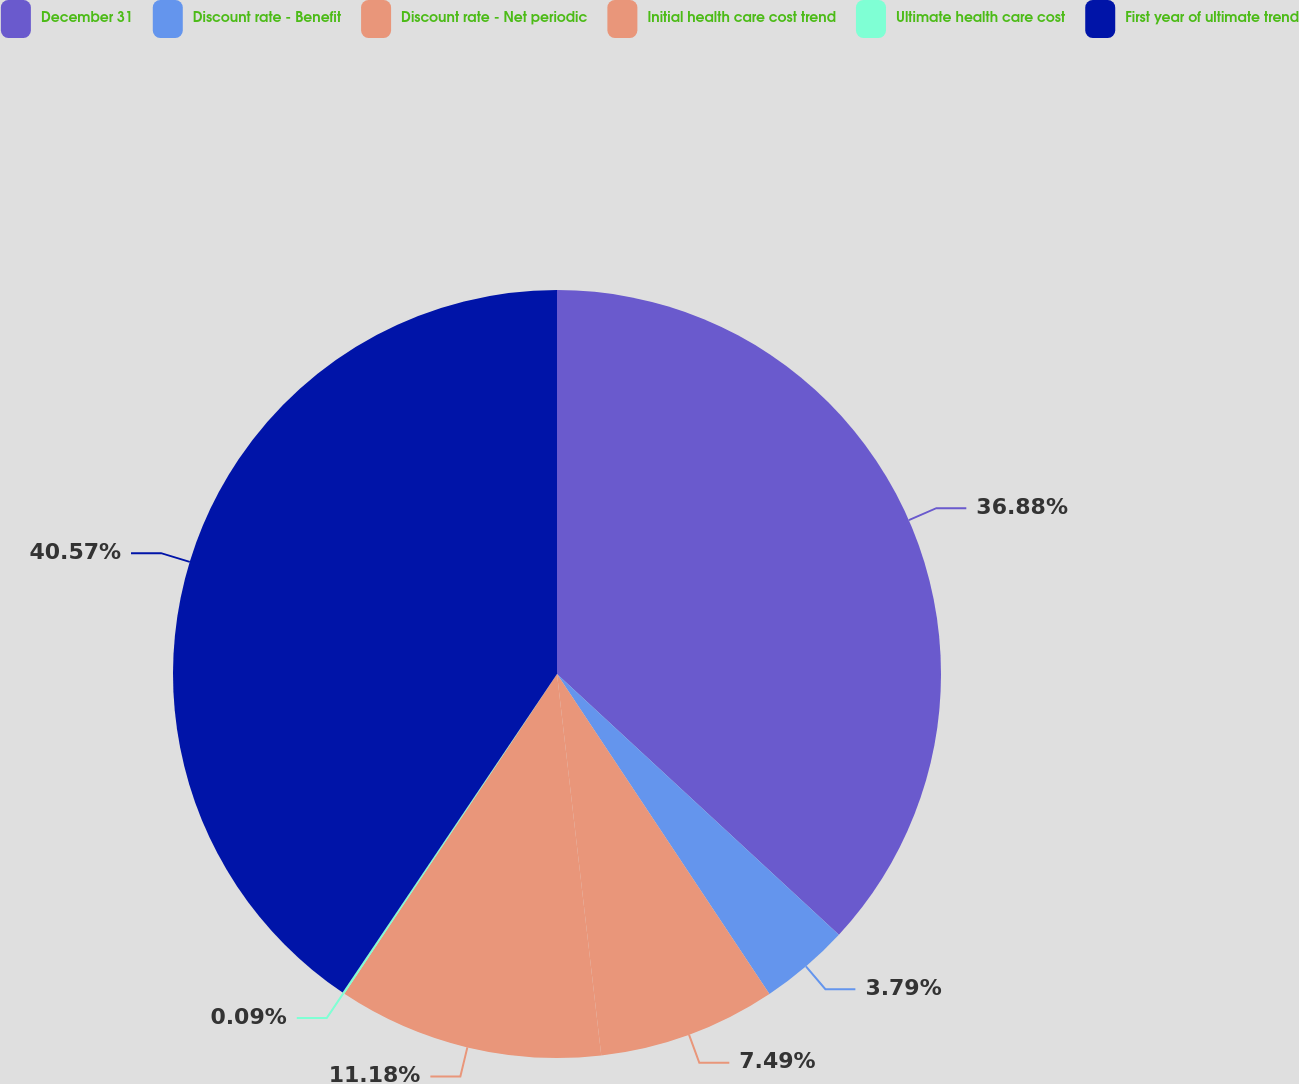Convert chart to OTSL. <chart><loc_0><loc_0><loc_500><loc_500><pie_chart><fcel>December 31<fcel>Discount rate - Benefit<fcel>Discount rate - Net periodic<fcel>Initial health care cost trend<fcel>Ultimate health care cost<fcel>First year of ultimate trend<nl><fcel>36.88%<fcel>3.79%<fcel>7.49%<fcel>11.18%<fcel>0.09%<fcel>40.57%<nl></chart> 